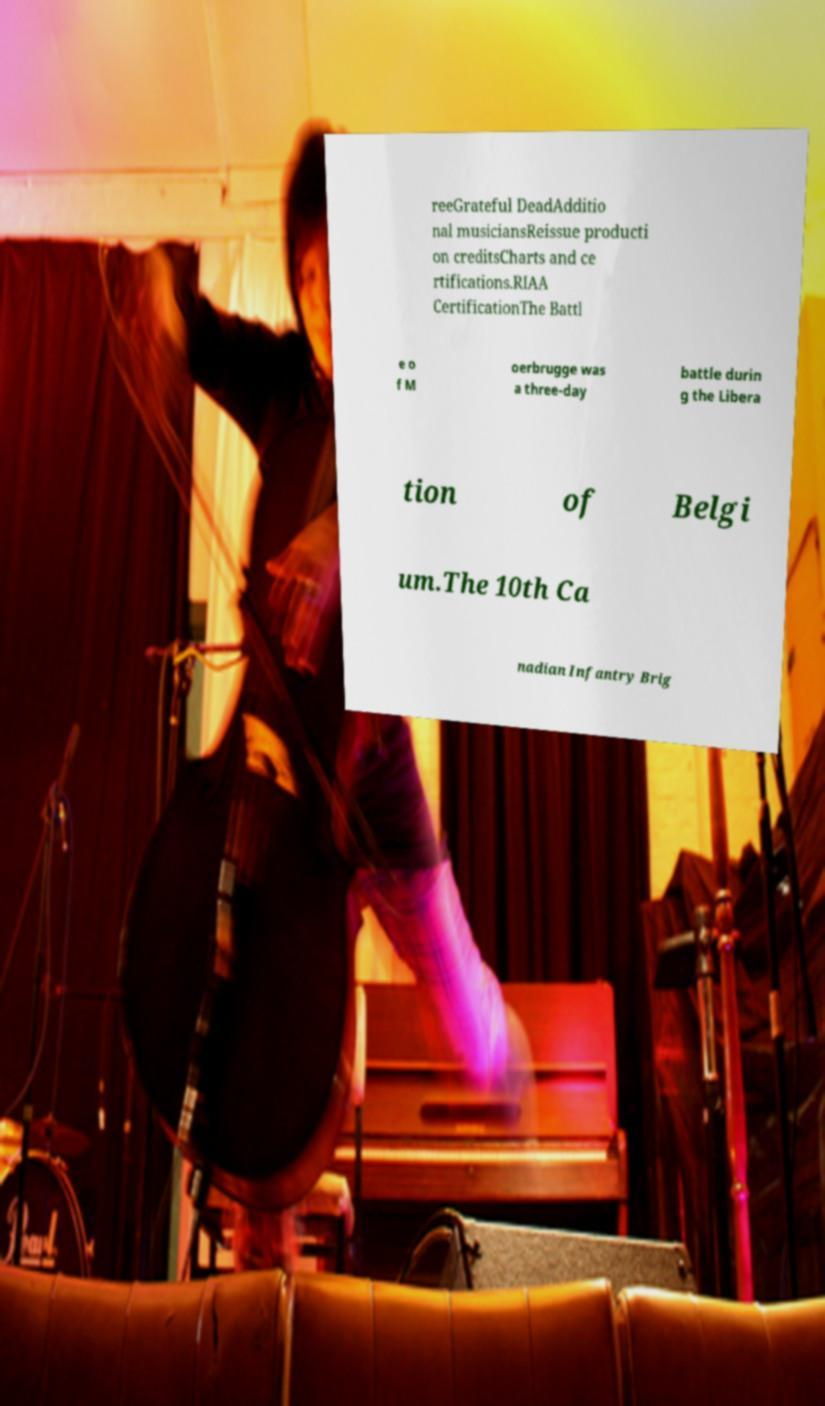Can you accurately transcribe the text from the provided image for me? reeGrateful DeadAdditio nal musiciansReissue producti on creditsCharts and ce rtifications.RIAA CertificationThe Battl e o f M oerbrugge was a three-day battle durin g the Libera tion of Belgi um.The 10th Ca nadian Infantry Brig 